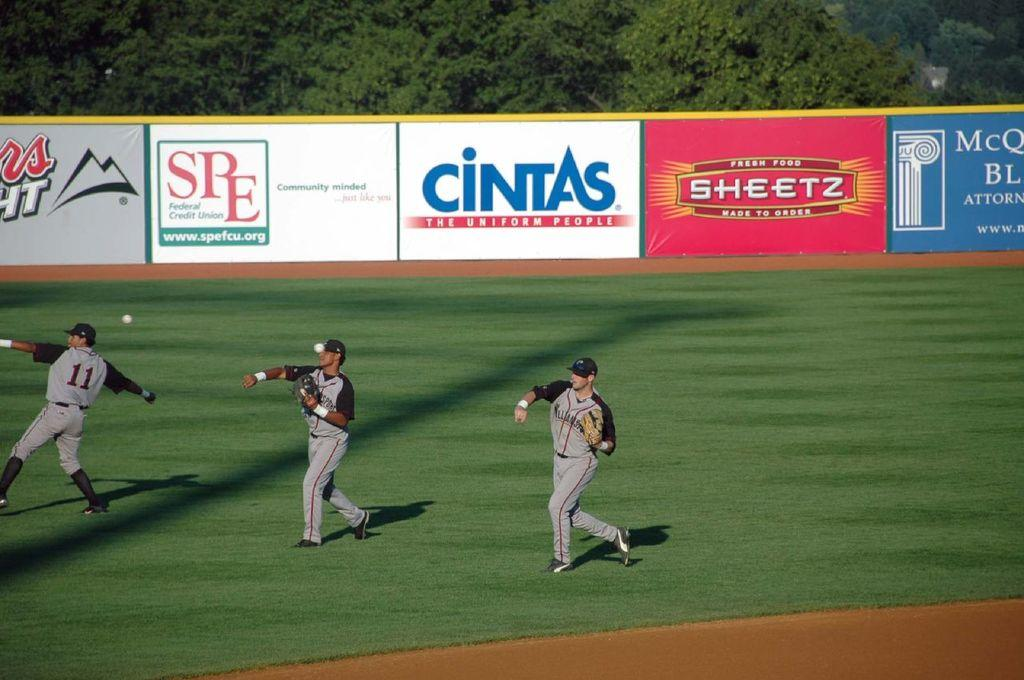Provide a one-sentence caption for the provided image. SPE and Cintas put ads around this field. 